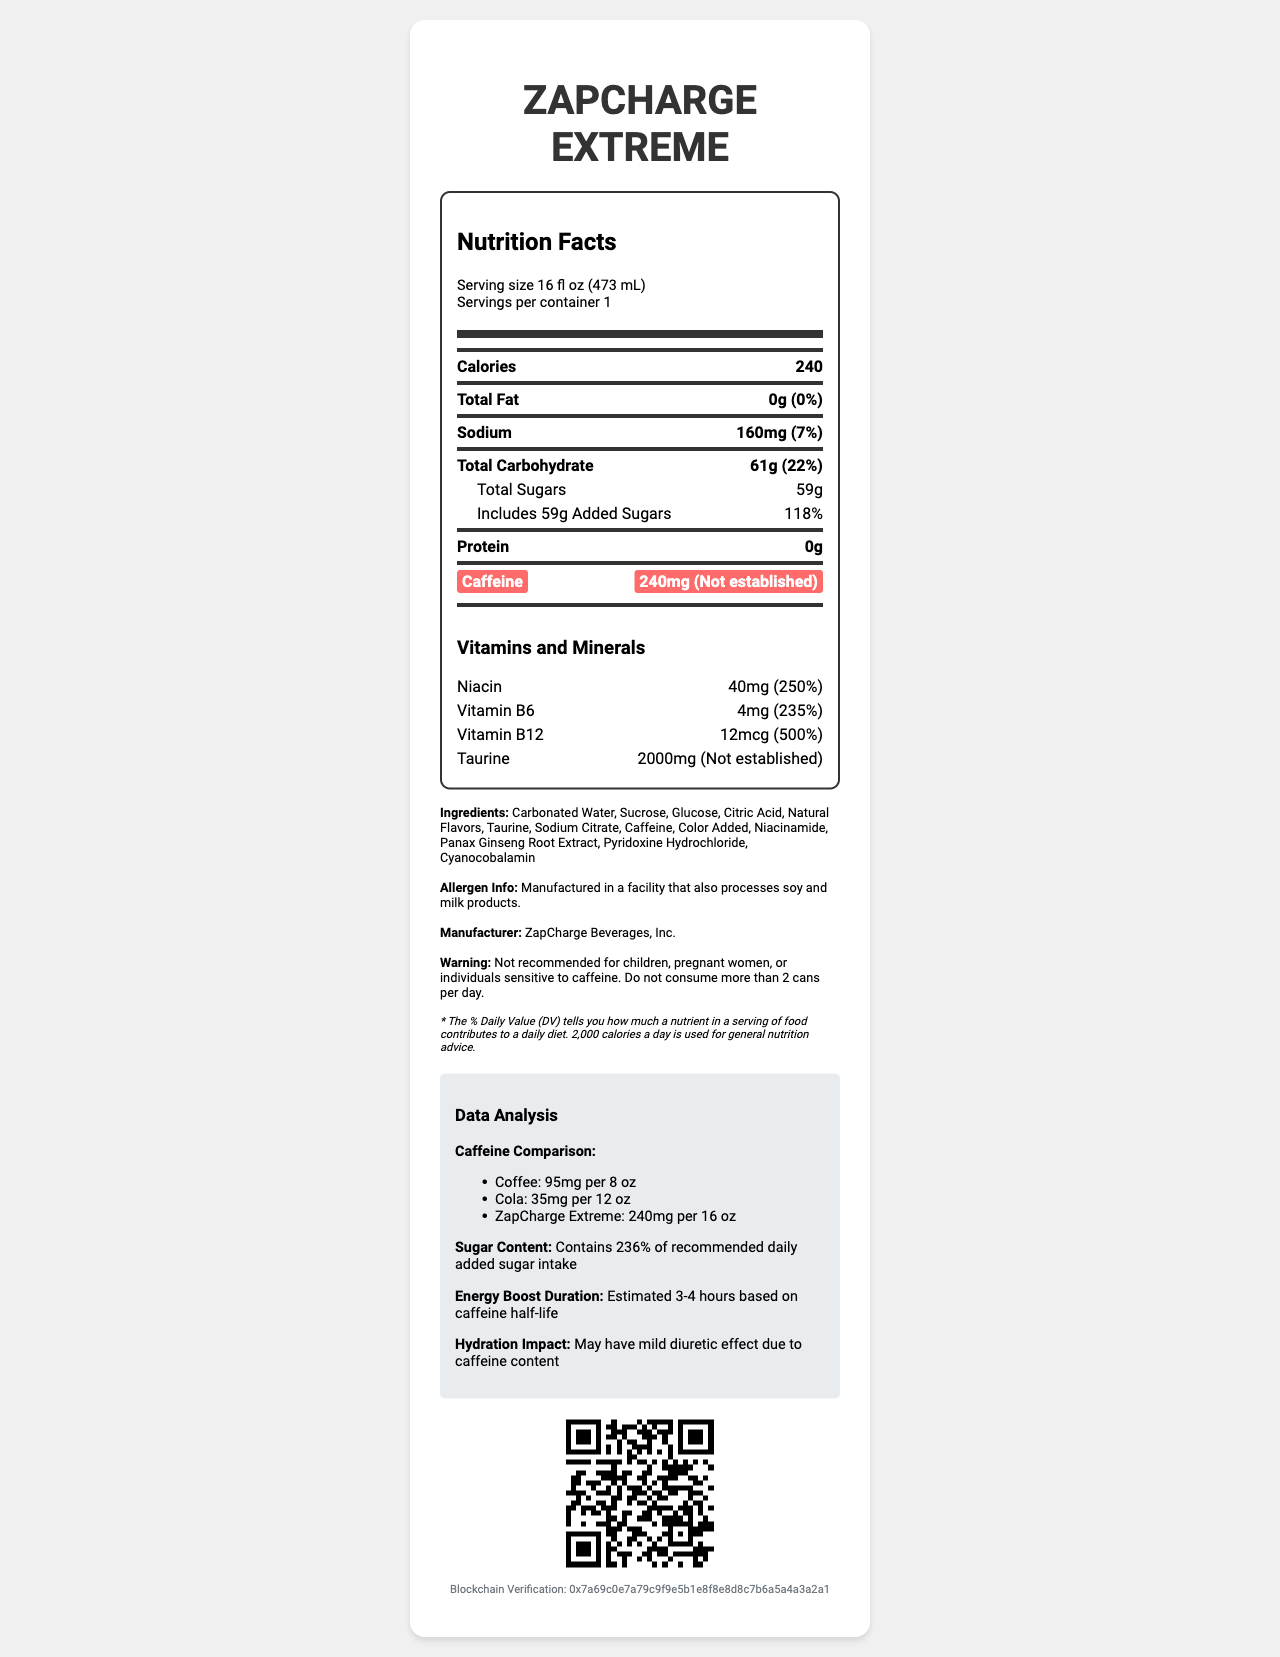what is the serving size? The serving size is explicitly stated at the beginning of the Nutrition Facts section.
Answer: 16 fl oz (473 mL) how much caffeine does ZapCharge Extreme contain per serving? The caffeine content is highlighted on the label, showing it contains 240mg per serving.
Answer: 240mg what is the daily value percentage of added sugars in this energy drink? The added sugars have a daily value of 118% as listed under the total sugars section.
Answer: 118% what vitamins are included in the ZapCharge Extreme, and in what amounts? The document lists the vitamins and their respective amounts under the "Vitamins and Minerals" section.
Answer: Niacin (40mg), Vitamin B6 (4mg), Vitamin B12 (12mcg), Taurine (2000mg) what is the warning associated with the consumption of this energy drink? This warning is found towards the bottom of the document in the warning section.
Answer: Not recommended for children, pregnant women, or individuals sensitive to caffeine. Do not consume more than 2 cans per day. how much sodium is in one serving of ZapCharge Extreme? The sodium content per serving is listed as 160mg under the sodium section.
Answer: 160mg what is the primary source of added sugars in this energy drink? The ingredients list includes Sucrose and Glucose, which are common sources of added sugars.
Answer: Sucrose, Glucose how does the caffeine content of ZapCharge Extreme compare to coffee? A. ZapCharge Extreme has less caffeine. B. Coffee has more caffeine. C. ZapCharge Extreme has more caffeine. D. They have the same caffeine content. The data analysis section shows ZapCharge Extreme (240mg per 16 oz) has more caffeine compared to coffee (95mg per 8 oz).
Answer: C what is the estimated duration of the energy boost provided by the caffeine in this drink? A. 1-2 hours B. 3-4 hours C. 5-6 hours D. 7-8 hours According to the data analysis section, the estimated energy boost duration is 3-4 hours based on caffeine half-life.
Answer: B does the document include information on potential allergen content? The allergen information section specifies that it is manufactured in a facility that also processes soy and milk products.
Answer: Yes describe the main information provided by the document The main idea of the document is to present detailed nutritional information about "ZapCharge Extreme," cautionary details on consumption, and comparisons with other beverages.
Answer: The document is a Nutrition Facts label for the energy drink "ZapCharge Extreme," highlighting its serving size, nutritional content, including calories, fats, sodium, carbohydrates, sugars, protein, caffeine, vitamins, and minerals. It also mentions its ingredients, allergen information, manufacturer details, warnings, and includes a data analysis section that compares caffeine content with other beverages and discusses the effects of sugar and caffeine. how many servings are there per container? The document states "Servings per container: 1" at the beginning of the Nutrition Facts.
Answer: 1 what is the total fat content in the energy drink? The total fat content is listed as 0g in the total fat section.
Answer: 0g what is the blockchain verification code for the document? The blockchain verification code is provided at the bottom of the document.
Answer: 0x7a69c0e7a79c9f9e5b1e8f8e8d8c7b6a5a4a3a2a1 what are the natural flavors added to the drink? The document lists "Natural Flavors" in the ingredients, but it doesn't specify what those natural flavors are.
Answer: Not enough information 